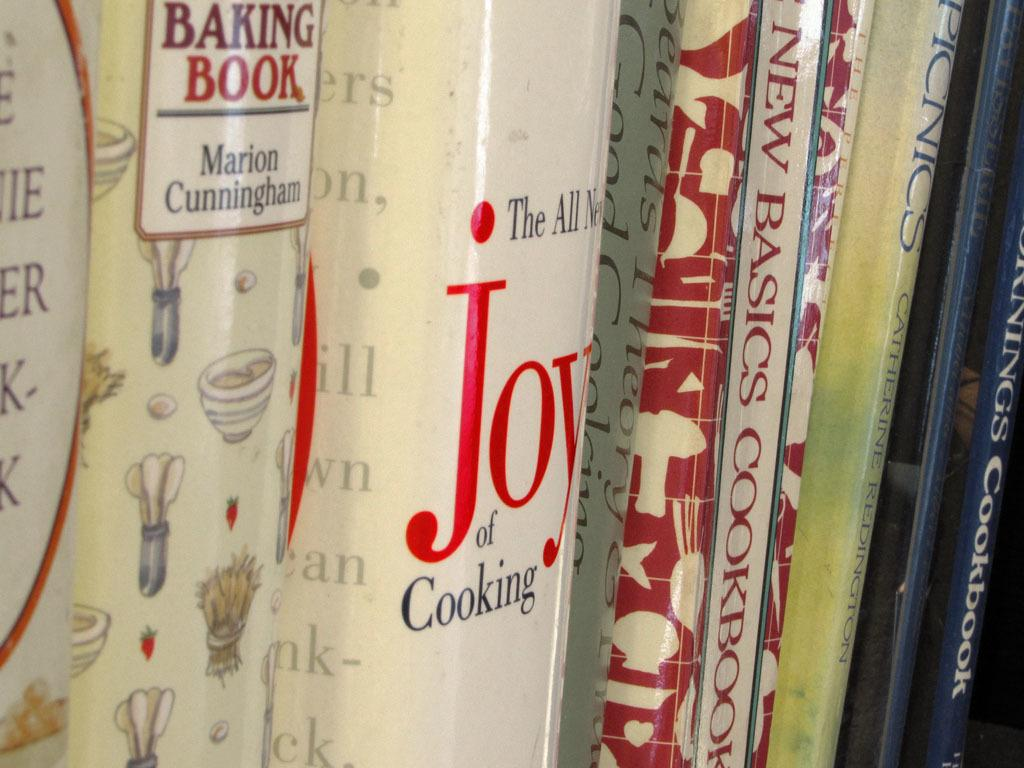<image>
Share a concise interpretation of the image provided. Several books are lined up, including the Joy of Cooking and a Baking Book. 